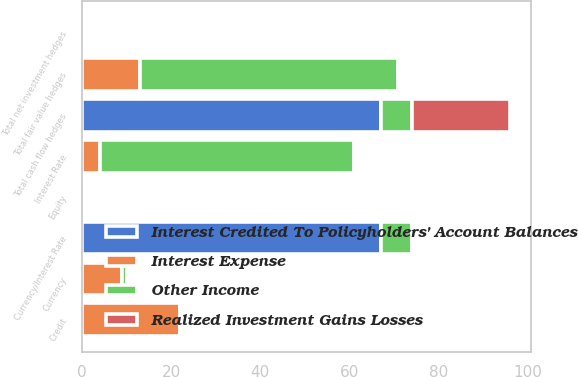<chart> <loc_0><loc_0><loc_500><loc_500><stacked_bar_chart><ecel><fcel>Interest Rate<fcel>Currency<fcel>Total fair value hedges<fcel>Currency/Interest Rate<fcel>Total cash flow hedges<fcel>Total net investment hedges<fcel>Credit<fcel>Equity<nl><fcel>Interest Expense<fcel>4<fcel>9<fcel>13<fcel>0<fcel>0<fcel>0<fcel>22<fcel>0<nl><fcel>Other Income<fcel>57<fcel>1<fcel>58<fcel>7<fcel>7<fcel>0<fcel>0<fcel>0<nl><fcel>Interest Credited To Policyholders' Account Balances<fcel>0<fcel>0<fcel>0<fcel>67<fcel>67<fcel>0<fcel>0<fcel>0<nl><fcel>Realized Investment Gains Losses<fcel>0<fcel>0<fcel>0<fcel>0<fcel>22<fcel>0<fcel>0<fcel>0<nl></chart> 